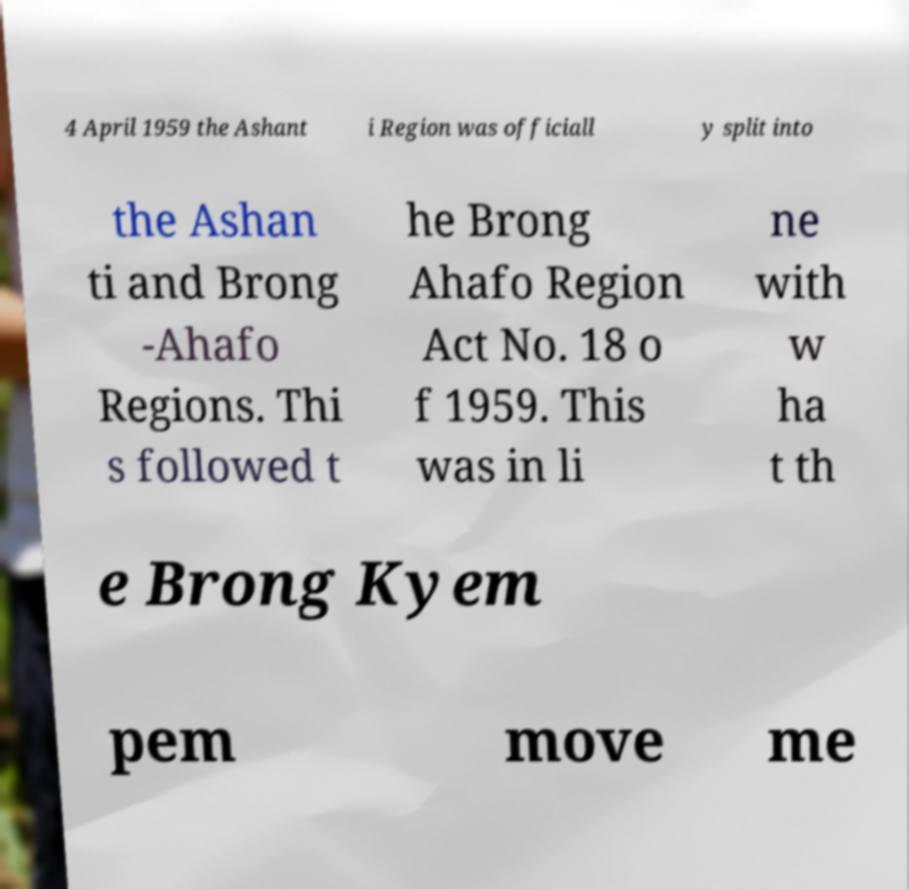Please identify and transcribe the text found in this image. 4 April 1959 the Ashant i Region was officiall y split into the Ashan ti and Brong -Ahafo Regions. Thi s followed t he Brong Ahafo Region Act No. 18 o f 1959. This was in li ne with w ha t th e Brong Kyem pem move me 